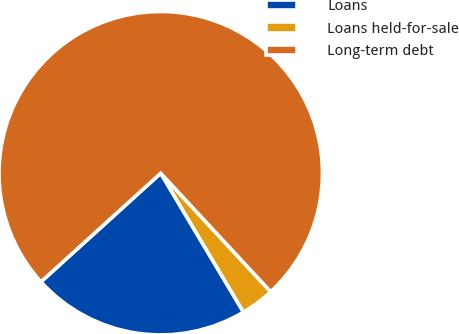Convert chart to OTSL. <chart><loc_0><loc_0><loc_500><loc_500><pie_chart><fcel>Loans<fcel>Loans held-for-sale<fcel>Long-term debt<nl><fcel>21.83%<fcel>3.35%<fcel>74.83%<nl></chart> 